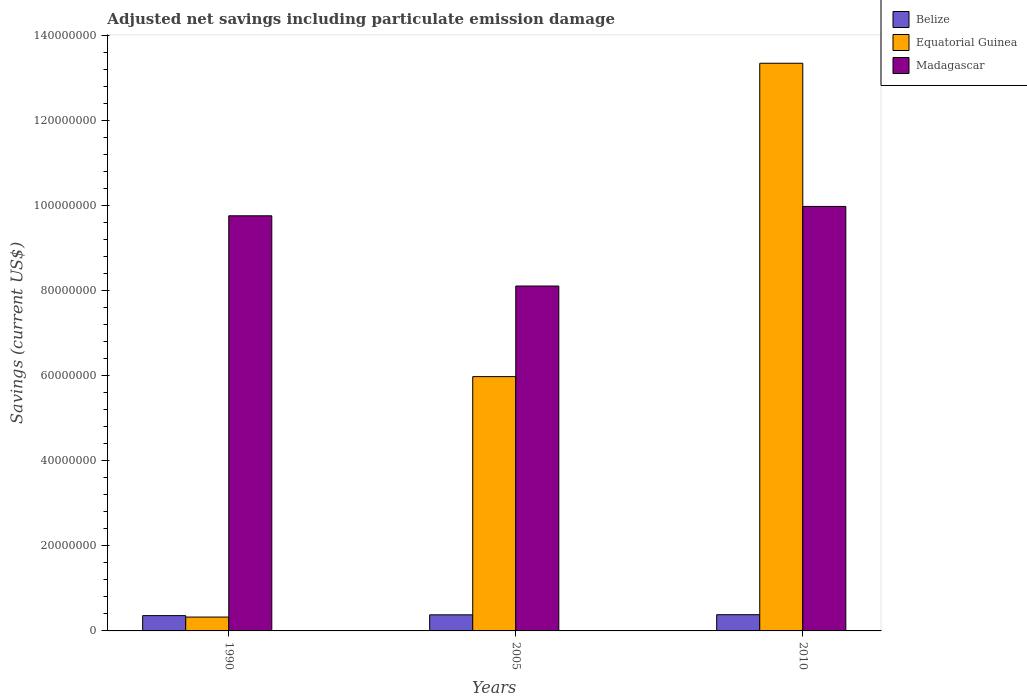How many different coloured bars are there?
Your response must be concise. 3. Are the number of bars on each tick of the X-axis equal?
Offer a terse response. Yes. How many bars are there on the 2nd tick from the right?
Provide a short and direct response. 3. What is the label of the 1st group of bars from the left?
Provide a succinct answer. 1990. In how many cases, is the number of bars for a given year not equal to the number of legend labels?
Provide a succinct answer. 0. What is the net savings in Equatorial Guinea in 1990?
Your response must be concise. 3.26e+06. Across all years, what is the maximum net savings in Madagascar?
Provide a short and direct response. 9.98e+07. Across all years, what is the minimum net savings in Madagascar?
Ensure brevity in your answer.  8.11e+07. In which year was the net savings in Equatorial Guinea maximum?
Your answer should be compact. 2010. In which year was the net savings in Belize minimum?
Provide a short and direct response. 1990. What is the total net savings in Belize in the graph?
Your answer should be compact. 1.12e+07. What is the difference between the net savings in Equatorial Guinea in 1990 and that in 2005?
Keep it short and to the point. -5.65e+07. What is the difference between the net savings in Belize in 2005 and the net savings in Equatorial Guinea in 1990?
Give a very brief answer. 5.20e+05. What is the average net savings in Belize per year?
Ensure brevity in your answer.  3.73e+06. In the year 2010, what is the difference between the net savings in Belize and net savings in Equatorial Guinea?
Offer a terse response. -1.30e+08. In how many years, is the net savings in Madagascar greater than 116000000 US$?
Keep it short and to the point. 0. What is the ratio of the net savings in Belize in 2005 to that in 2010?
Your response must be concise. 0.99. Is the net savings in Madagascar in 2005 less than that in 2010?
Keep it short and to the point. Yes. Is the difference between the net savings in Belize in 1990 and 2005 greater than the difference between the net savings in Equatorial Guinea in 1990 and 2005?
Give a very brief answer. Yes. What is the difference between the highest and the second highest net savings in Equatorial Guinea?
Keep it short and to the point. 7.37e+07. What is the difference between the highest and the lowest net savings in Madagascar?
Your answer should be compact. 1.87e+07. Is the sum of the net savings in Madagascar in 1990 and 2005 greater than the maximum net savings in Equatorial Guinea across all years?
Offer a very short reply. Yes. What does the 3rd bar from the left in 2005 represents?
Ensure brevity in your answer.  Madagascar. What does the 2nd bar from the right in 1990 represents?
Your answer should be very brief. Equatorial Guinea. How many bars are there?
Provide a succinct answer. 9. Are all the bars in the graph horizontal?
Your answer should be very brief. No. Does the graph contain any zero values?
Provide a succinct answer. No. Does the graph contain grids?
Give a very brief answer. No. How many legend labels are there?
Provide a short and direct response. 3. What is the title of the graph?
Offer a very short reply. Adjusted net savings including particulate emission damage. Does "Mongolia" appear as one of the legend labels in the graph?
Give a very brief answer. No. What is the label or title of the X-axis?
Give a very brief answer. Years. What is the label or title of the Y-axis?
Provide a succinct answer. Savings (current US$). What is the Savings (current US$) of Belize in 1990?
Offer a very short reply. 3.60e+06. What is the Savings (current US$) in Equatorial Guinea in 1990?
Give a very brief answer. 3.26e+06. What is the Savings (current US$) of Madagascar in 1990?
Offer a terse response. 9.76e+07. What is the Savings (current US$) of Belize in 2005?
Your answer should be very brief. 3.78e+06. What is the Savings (current US$) in Equatorial Guinea in 2005?
Provide a short and direct response. 5.98e+07. What is the Savings (current US$) of Madagascar in 2005?
Your answer should be very brief. 8.11e+07. What is the Savings (current US$) in Belize in 2010?
Provide a short and direct response. 3.82e+06. What is the Savings (current US$) of Equatorial Guinea in 2010?
Keep it short and to the point. 1.34e+08. What is the Savings (current US$) in Madagascar in 2010?
Ensure brevity in your answer.  9.98e+07. Across all years, what is the maximum Savings (current US$) in Belize?
Your answer should be very brief. 3.82e+06. Across all years, what is the maximum Savings (current US$) of Equatorial Guinea?
Give a very brief answer. 1.34e+08. Across all years, what is the maximum Savings (current US$) in Madagascar?
Provide a short and direct response. 9.98e+07. Across all years, what is the minimum Savings (current US$) in Belize?
Ensure brevity in your answer.  3.60e+06. Across all years, what is the minimum Savings (current US$) of Equatorial Guinea?
Give a very brief answer. 3.26e+06. Across all years, what is the minimum Savings (current US$) in Madagascar?
Provide a short and direct response. 8.11e+07. What is the total Savings (current US$) in Belize in the graph?
Ensure brevity in your answer.  1.12e+07. What is the total Savings (current US$) of Equatorial Guinea in the graph?
Your answer should be very brief. 1.97e+08. What is the total Savings (current US$) in Madagascar in the graph?
Keep it short and to the point. 2.79e+08. What is the difference between the Savings (current US$) in Belize in 1990 and that in 2005?
Ensure brevity in your answer.  -1.86e+05. What is the difference between the Savings (current US$) of Equatorial Guinea in 1990 and that in 2005?
Provide a succinct answer. -5.65e+07. What is the difference between the Savings (current US$) in Madagascar in 1990 and that in 2005?
Give a very brief answer. 1.65e+07. What is the difference between the Savings (current US$) of Belize in 1990 and that in 2010?
Provide a succinct answer. -2.20e+05. What is the difference between the Savings (current US$) in Equatorial Guinea in 1990 and that in 2010?
Your answer should be very brief. -1.30e+08. What is the difference between the Savings (current US$) in Madagascar in 1990 and that in 2010?
Ensure brevity in your answer.  -2.20e+06. What is the difference between the Savings (current US$) of Belize in 2005 and that in 2010?
Your answer should be very brief. -3.43e+04. What is the difference between the Savings (current US$) of Equatorial Guinea in 2005 and that in 2010?
Keep it short and to the point. -7.37e+07. What is the difference between the Savings (current US$) of Madagascar in 2005 and that in 2010?
Your answer should be very brief. -1.87e+07. What is the difference between the Savings (current US$) in Belize in 1990 and the Savings (current US$) in Equatorial Guinea in 2005?
Make the answer very short. -5.62e+07. What is the difference between the Savings (current US$) of Belize in 1990 and the Savings (current US$) of Madagascar in 2005?
Make the answer very short. -7.75e+07. What is the difference between the Savings (current US$) of Equatorial Guinea in 1990 and the Savings (current US$) of Madagascar in 2005?
Give a very brief answer. -7.79e+07. What is the difference between the Savings (current US$) of Belize in 1990 and the Savings (current US$) of Equatorial Guinea in 2010?
Your response must be concise. -1.30e+08. What is the difference between the Savings (current US$) in Belize in 1990 and the Savings (current US$) in Madagascar in 2010?
Offer a terse response. -9.62e+07. What is the difference between the Savings (current US$) of Equatorial Guinea in 1990 and the Savings (current US$) of Madagascar in 2010?
Provide a succinct answer. -9.66e+07. What is the difference between the Savings (current US$) in Belize in 2005 and the Savings (current US$) in Equatorial Guinea in 2010?
Provide a short and direct response. -1.30e+08. What is the difference between the Savings (current US$) of Belize in 2005 and the Savings (current US$) of Madagascar in 2010?
Give a very brief answer. -9.61e+07. What is the difference between the Savings (current US$) of Equatorial Guinea in 2005 and the Savings (current US$) of Madagascar in 2010?
Offer a terse response. -4.00e+07. What is the average Savings (current US$) of Belize per year?
Your answer should be compact. 3.73e+06. What is the average Savings (current US$) in Equatorial Guinea per year?
Offer a very short reply. 6.55e+07. What is the average Savings (current US$) in Madagascar per year?
Your answer should be compact. 9.29e+07. In the year 1990, what is the difference between the Savings (current US$) of Belize and Savings (current US$) of Equatorial Guinea?
Give a very brief answer. 3.34e+05. In the year 1990, what is the difference between the Savings (current US$) of Belize and Savings (current US$) of Madagascar?
Make the answer very short. -9.40e+07. In the year 1990, what is the difference between the Savings (current US$) in Equatorial Guinea and Savings (current US$) in Madagascar?
Offer a very short reply. -9.44e+07. In the year 2005, what is the difference between the Savings (current US$) in Belize and Savings (current US$) in Equatorial Guinea?
Make the answer very short. -5.60e+07. In the year 2005, what is the difference between the Savings (current US$) in Belize and Savings (current US$) in Madagascar?
Provide a short and direct response. -7.73e+07. In the year 2005, what is the difference between the Savings (current US$) in Equatorial Guinea and Savings (current US$) in Madagascar?
Ensure brevity in your answer.  -2.13e+07. In the year 2010, what is the difference between the Savings (current US$) of Belize and Savings (current US$) of Equatorial Guinea?
Provide a short and direct response. -1.30e+08. In the year 2010, what is the difference between the Savings (current US$) in Belize and Savings (current US$) in Madagascar?
Offer a very short reply. -9.60e+07. In the year 2010, what is the difference between the Savings (current US$) in Equatorial Guinea and Savings (current US$) in Madagascar?
Your answer should be compact. 3.37e+07. What is the ratio of the Savings (current US$) in Belize in 1990 to that in 2005?
Your answer should be compact. 0.95. What is the ratio of the Savings (current US$) of Equatorial Guinea in 1990 to that in 2005?
Give a very brief answer. 0.05. What is the ratio of the Savings (current US$) of Madagascar in 1990 to that in 2005?
Offer a terse response. 1.2. What is the ratio of the Savings (current US$) of Belize in 1990 to that in 2010?
Your answer should be very brief. 0.94. What is the ratio of the Savings (current US$) in Equatorial Guinea in 1990 to that in 2010?
Ensure brevity in your answer.  0.02. What is the ratio of the Savings (current US$) in Equatorial Guinea in 2005 to that in 2010?
Provide a short and direct response. 0.45. What is the ratio of the Savings (current US$) of Madagascar in 2005 to that in 2010?
Provide a succinct answer. 0.81. What is the difference between the highest and the second highest Savings (current US$) of Belize?
Give a very brief answer. 3.43e+04. What is the difference between the highest and the second highest Savings (current US$) of Equatorial Guinea?
Provide a short and direct response. 7.37e+07. What is the difference between the highest and the second highest Savings (current US$) of Madagascar?
Your response must be concise. 2.20e+06. What is the difference between the highest and the lowest Savings (current US$) of Belize?
Ensure brevity in your answer.  2.20e+05. What is the difference between the highest and the lowest Savings (current US$) of Equatorial Guinea?
Ensure brevity in your answer.  1.30e+08. What is the difference between the highest and the lowest Savings (current US$) of Madagascar?
Make the answer very short. 1.87e+07. 